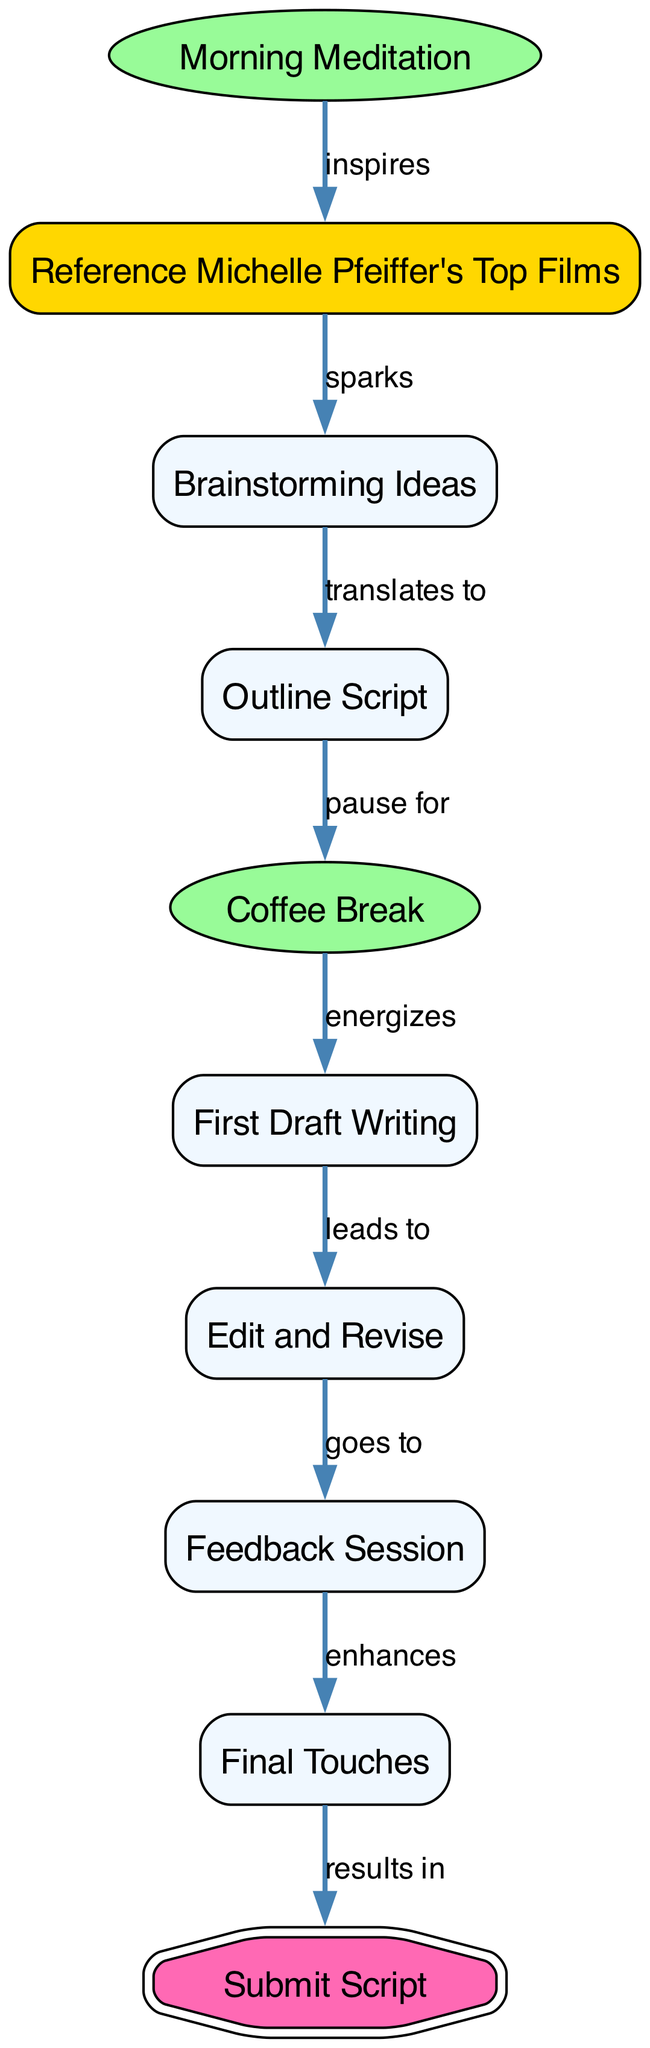What is the first activity in the daily routine? The diagram indicates that the first node in the sequence is "Morning Meditation". This is the starting point of the food chain, which leads to the next activities.
Answer: Morning Meditation How many nodes are there in the diagram? By counting all the nodes listed in the diagram, there are a total of 10 distinct activities performed by the screenwriter during their daily routine.
Answer: 10 What does "Coffee Break" lead to? The edge connecting "Coffee Break" to "First Draft Writing" shows that after taking a coffee break, the next step is to begin writing the first draft of the script.
Answer: First Draft Writing Which activity is highlighted as a break? The nodes "Morning Meditation" and "Coffee Break" are both highlighted specifically as breaks in the diagram, indicating their special role in the daily routine.
Answer: Morning Meditation, Coffee Break What enhances the feedback session? According to the diagram, the edge from "Feedback Session" to "Final Touches" signifies that the feedback received enhances the final polished aspect of the script, leading to the concluding step.
Answer: Final Touches What is the relationship between "Outline Script" and "Coffee Break"? The diagram states that "Outline Script" pauses for "Coffee Break", indicating a direct causal relationship where taking a break follows outlining.
Answer: pause for Which node sparks brainstorming ideas? The node labeled "Reference Michelle Pfeiffer's Top Films" directly sparks "Brainstorming Ideas," indicating its inspirational role in the creativity process of the screenwriter.
Answer: Brainstorming Ideas How many edges are in the diagram? By counting the connections between the nodes in the diagram, there are 9 edges that represent the relationships and flow between the different activities.
Answer: 9 What is the final activity before submitting the script? The diagram shows that "Final Touches" is the last step before the node "Submit Script", indicating what must be done to finalize the script before submission.
Answer: Final Touches Which node serves as an inspirational starting point for the creative process? "Morning Meditation" is identified as the inspirational starting point that sets the tone for the screenwriter's creative process, according to the diagram's flow.
Answer: Morning Meditation 